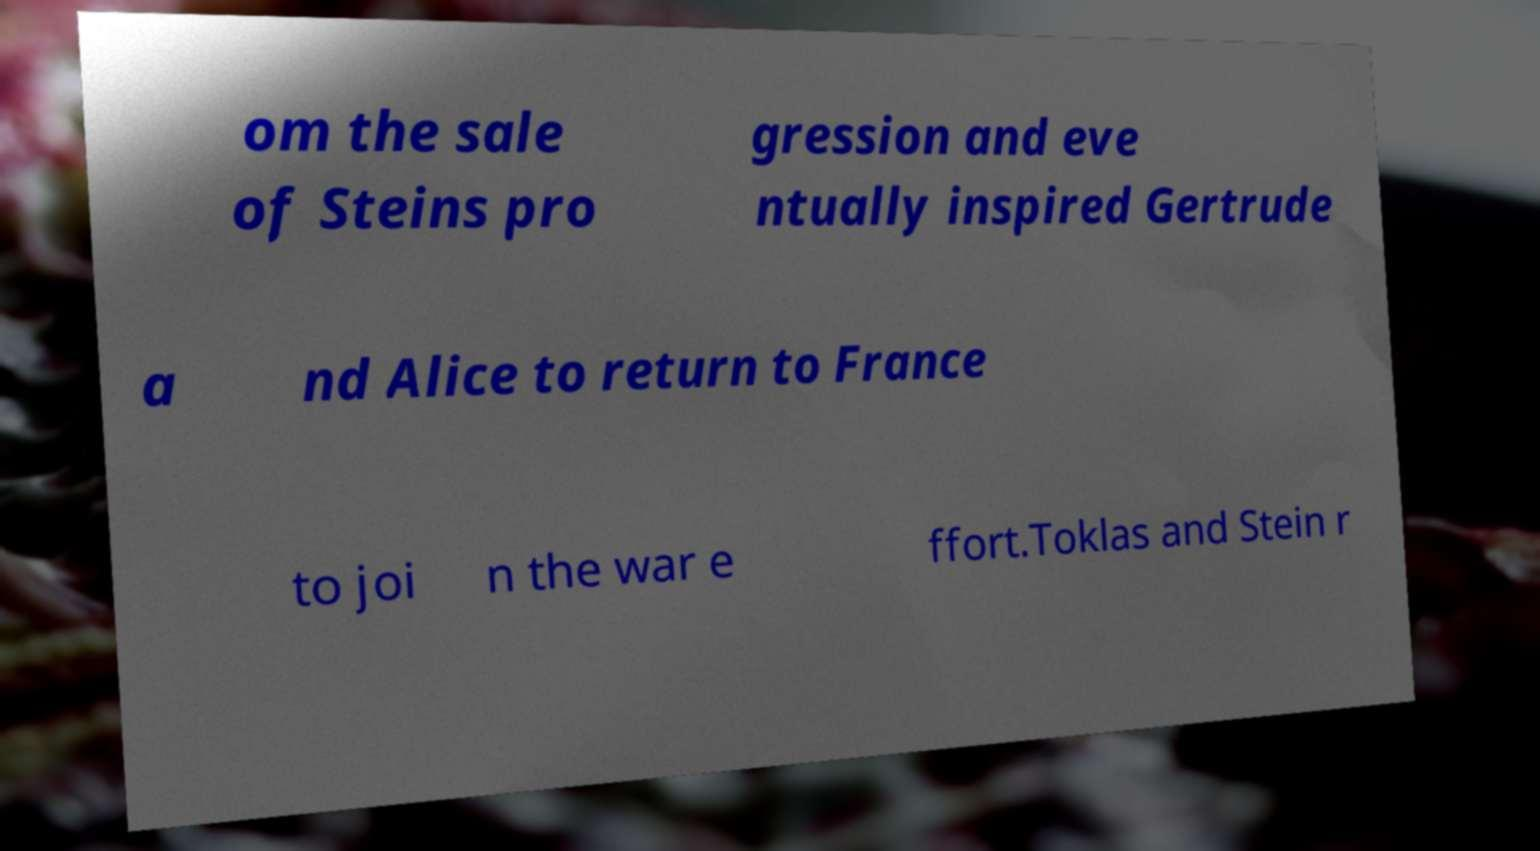Can you read and provide the text displayed in the image?This photo seems to have some interesting text. Can you extract and type it out for me? om the sale of Steins pro gression and eve ntually inspired Gertrude a nd Alice to return to France to joi n the war e ffort.Toklas and Stein r 